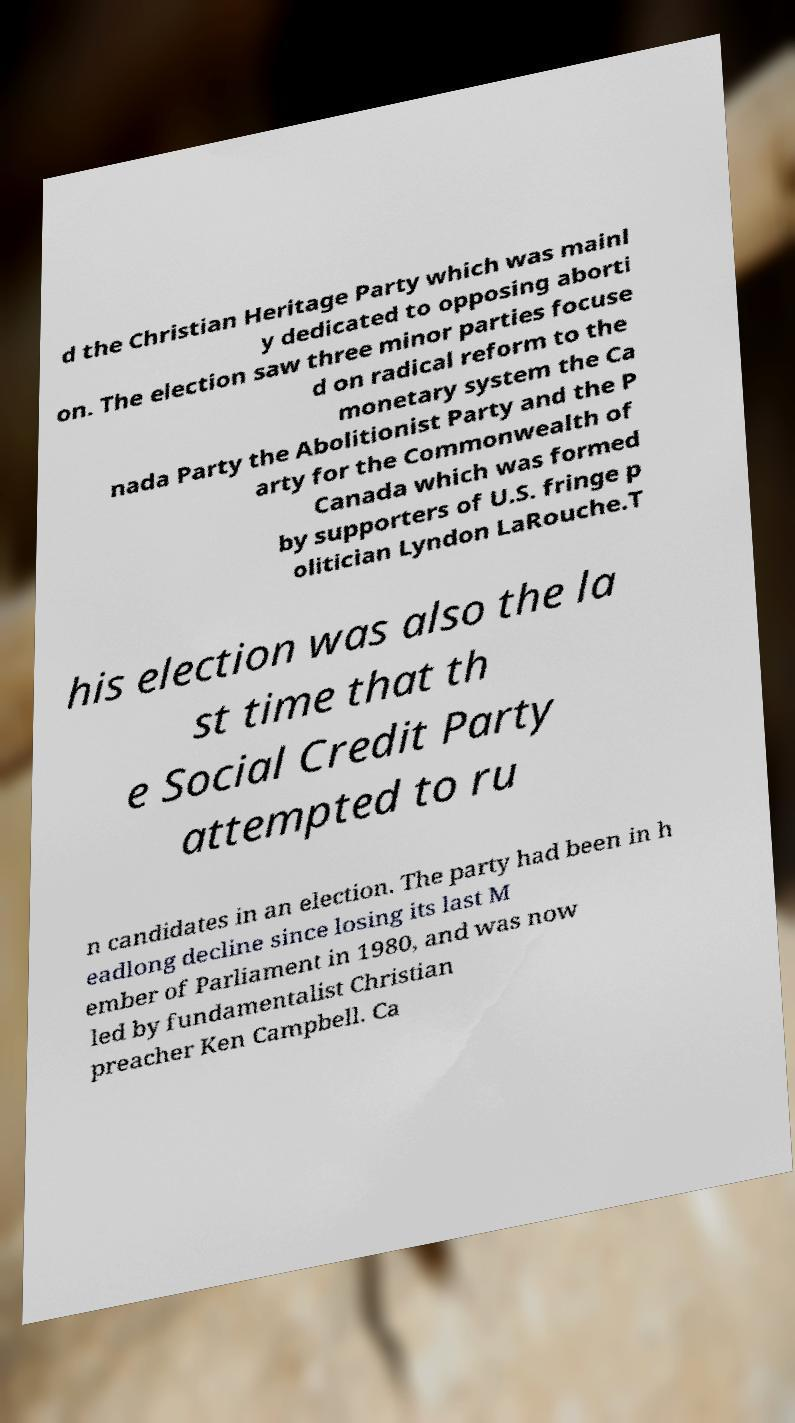Could you extract and type out the text from this image? d the Christian Heritage Party which was mainl y dedicated to opposing aborti on. The election saw three minor parties focuse d on radical reform to the monetary system the Ca nada Party the Abolitionist Party and the P arty for the Commonwealth of Canada which was formed by supporters of U.S. fringe p olitician Lyndon LaRouche.T his election was also the la st time that th e Social Credit Party attempted to ru n candidates in an election. The party had been in h eadlong decline since losing its last M ember of Parliament in 1980, and was now led by fundamentalist Christian preacher Ken Campbell. Ca 